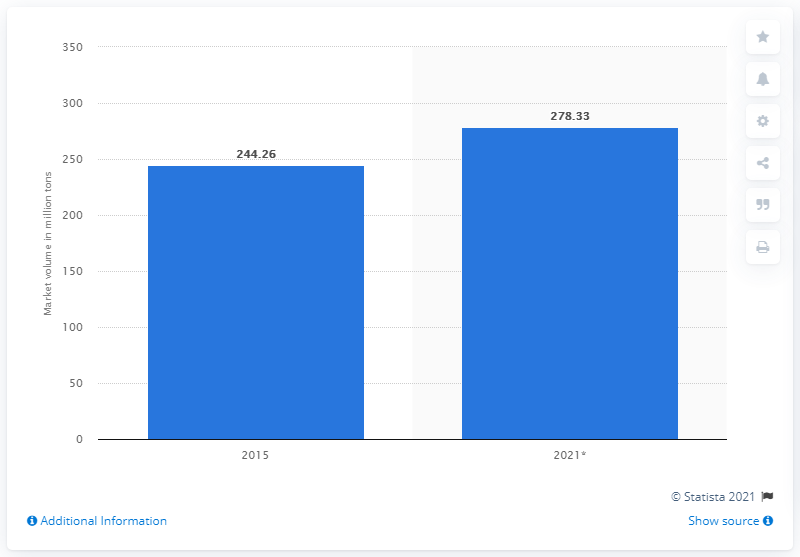Draw attention to some important aspects in this diagram. According to projections, the global market size of sulfuric acid is expected to reach 278.33 in 2021. 